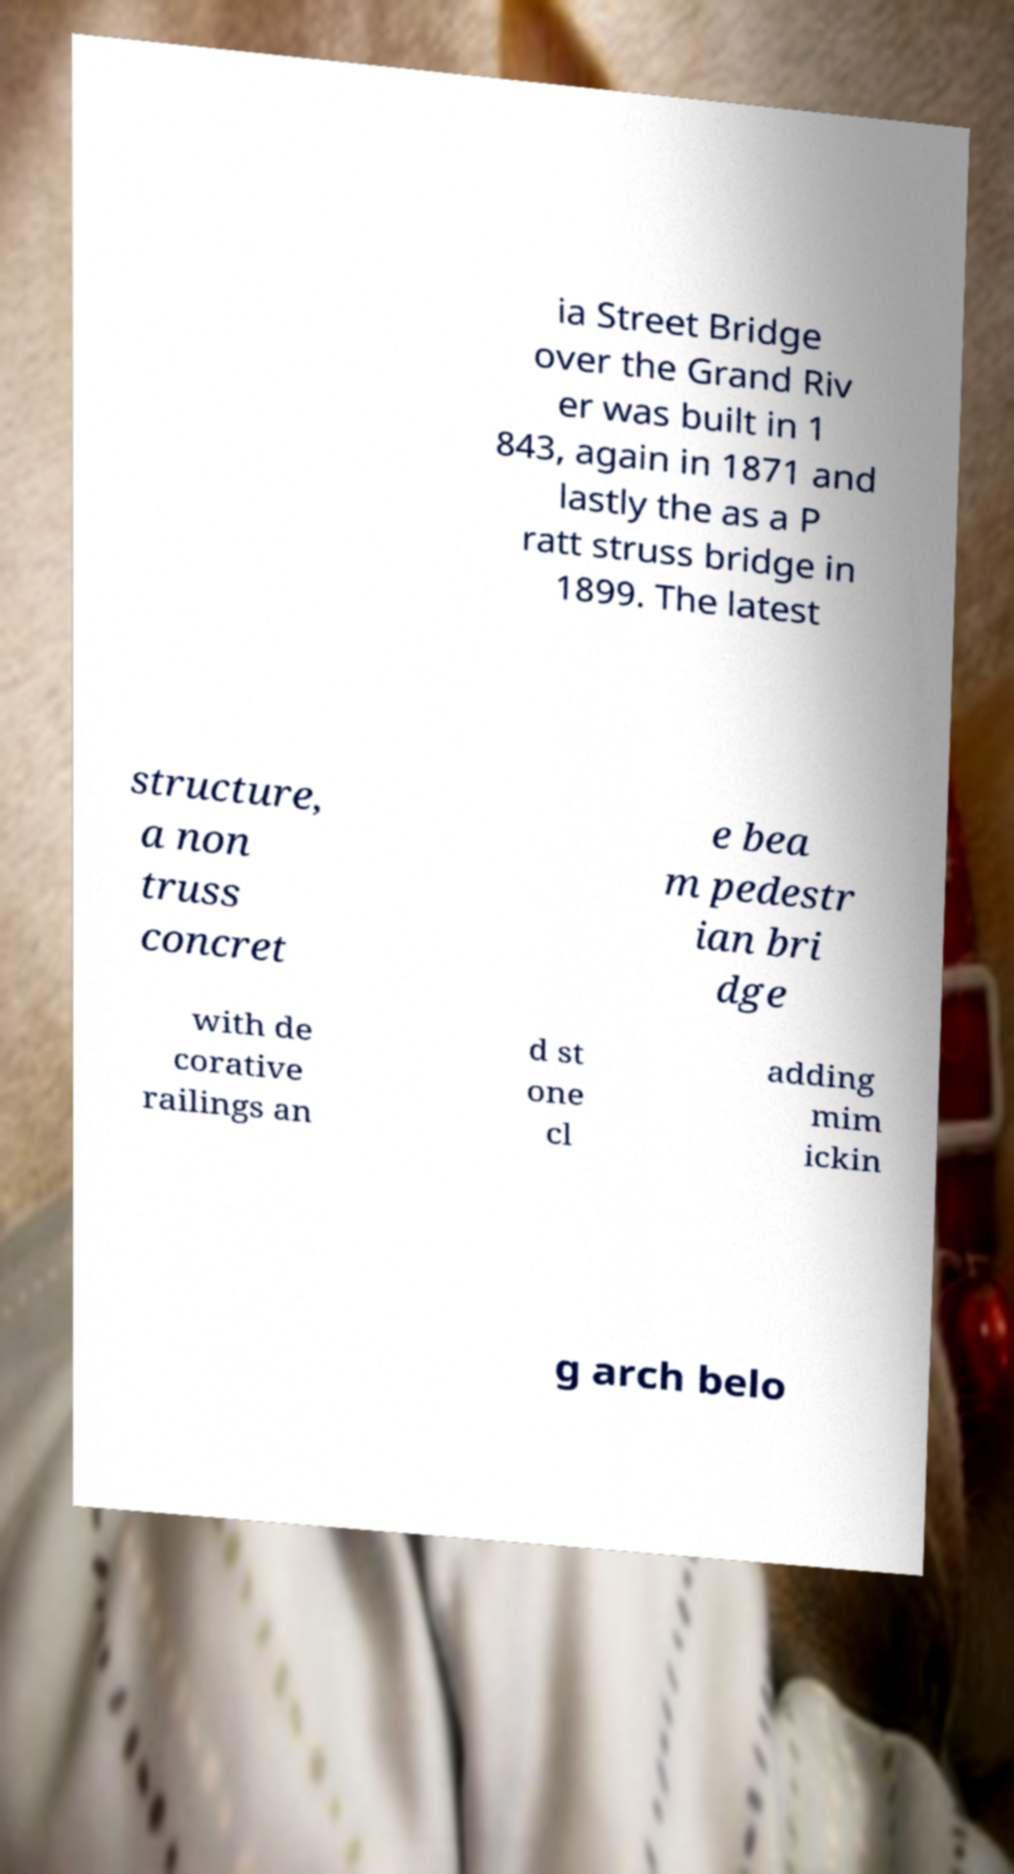I need the written content from this picture converted into text. Can you do that? ia Street Bridge over the Grand Riv er was built in 1 843, again in 1871 and lastly the as a P ratt struss bridge in 1899. The latest structure, a non truss concret e bea m pedestr ian bri dge with de corative railings an d st one cl adding mim ickin g arch belo 